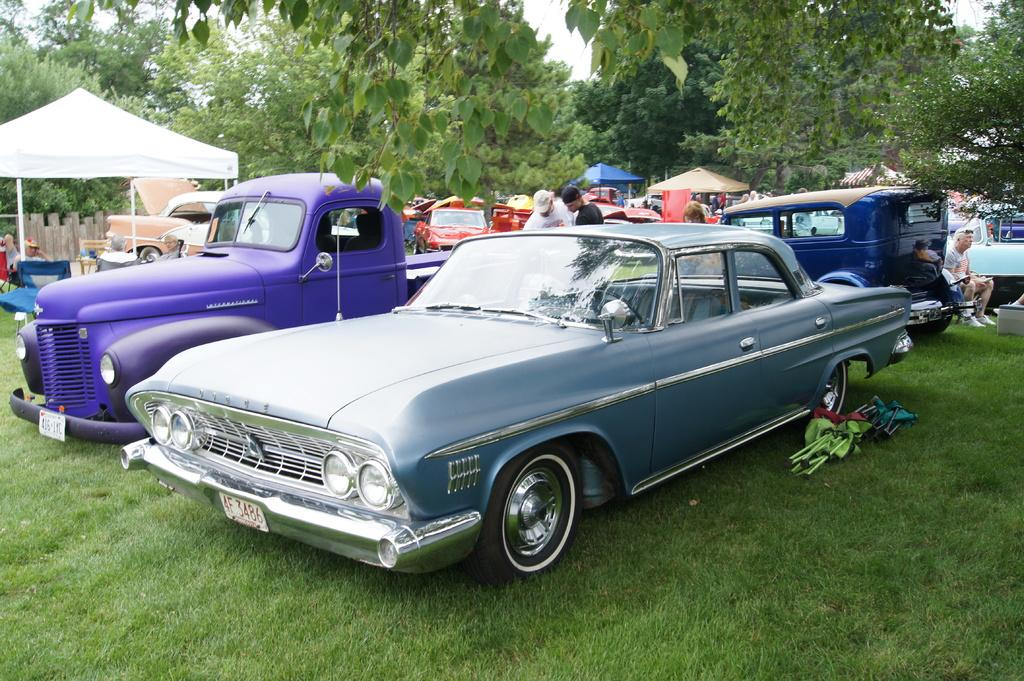What types of objects can be seen in the image? There are vehicles in the image. What type of natural environment is visible in the image? There is grass visible in the image. What type of temporary shelters can be seen in the image? There are tents in the image. What type of vegetation is present in the image? There are trees in the image. Who or what is present in the image? There are people in the image. What type of hope can be seen in the image? There is no hope present in the image; it is a visual representation of vehicles, grass, tents, trees, and people. What is the mass of the largest vehicle in the image? The provided facts do not include information about the size or mass of the vehicles, so it cannot be determined from the image. 